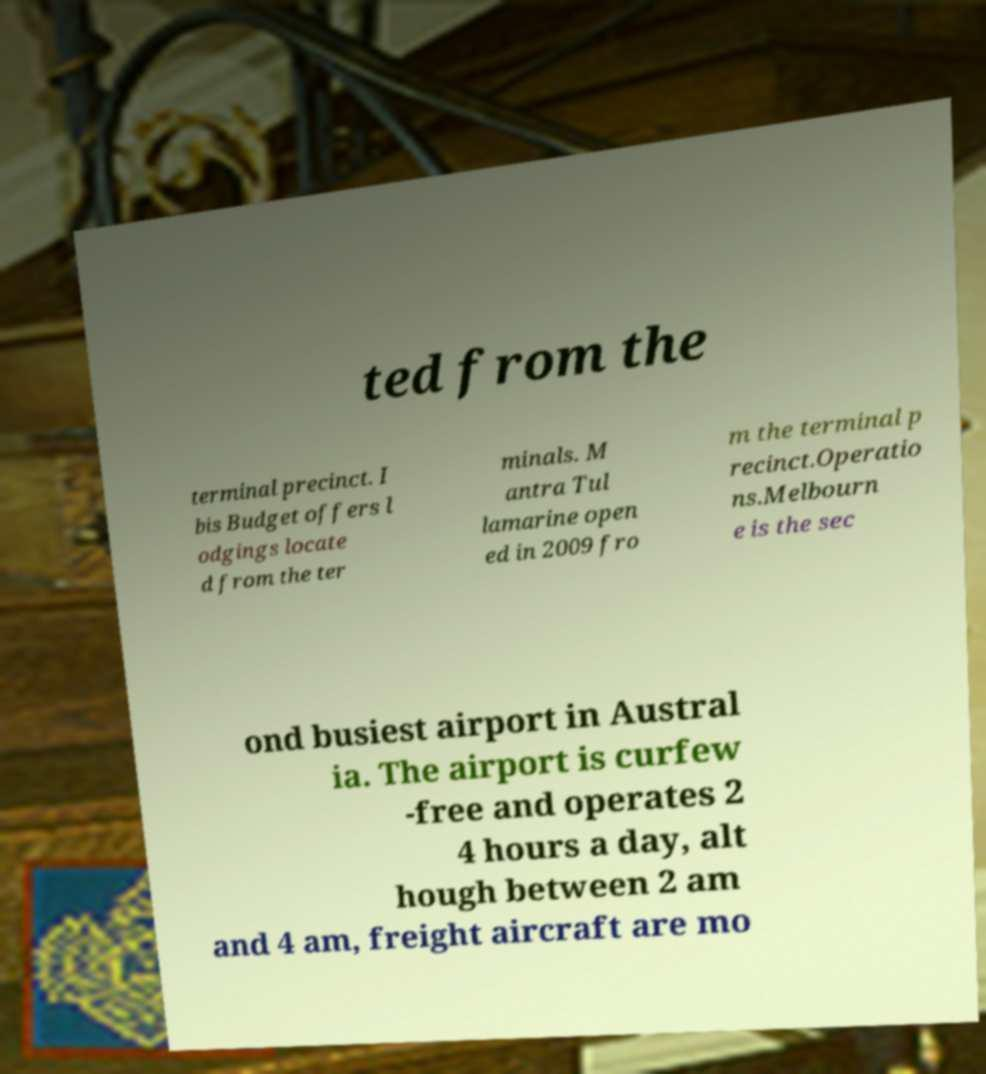There's text embedded in this image that I need extracted. Can you transcribe it verbatim? ted from the terminal precinct. I bis Budget offers l odgings locate d from the ter minals. M antra Tul lamarine open ed in 2009 fro m the terminal p recinct.Operatio ns.Melbourn e is the sec ond busiest airport in Austral ia. The airport is curfew -free and operates 2 4 hours a day, alt hough between 2 am and 4 am, freight aircraft are mo 